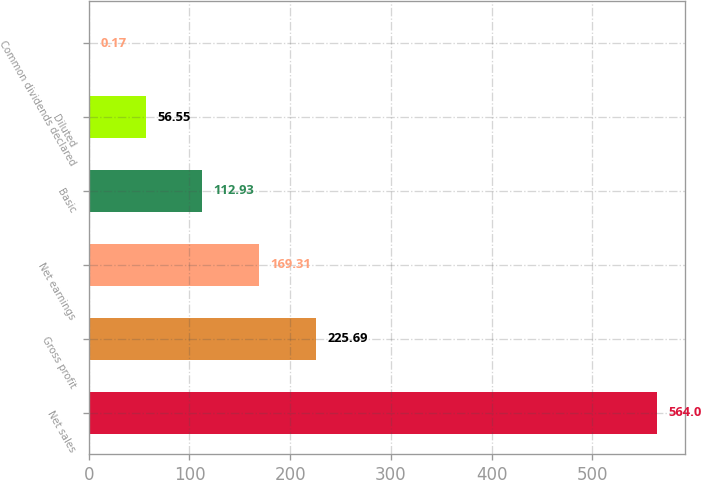Convert chart. <chart><loc_0><loc_0><loc_500><loc_500><bar_chart><fcel>Net sales<fcel>Gross profit<fcel>Net earnings<fcel>Basic<fcel>Diluted<fcel>Common dividends declared<nl><fcel>564<fcel>225.69<fcel>169.31<fcel>112.93<fcel>56.55<fcel>0.17<nl></chart> 